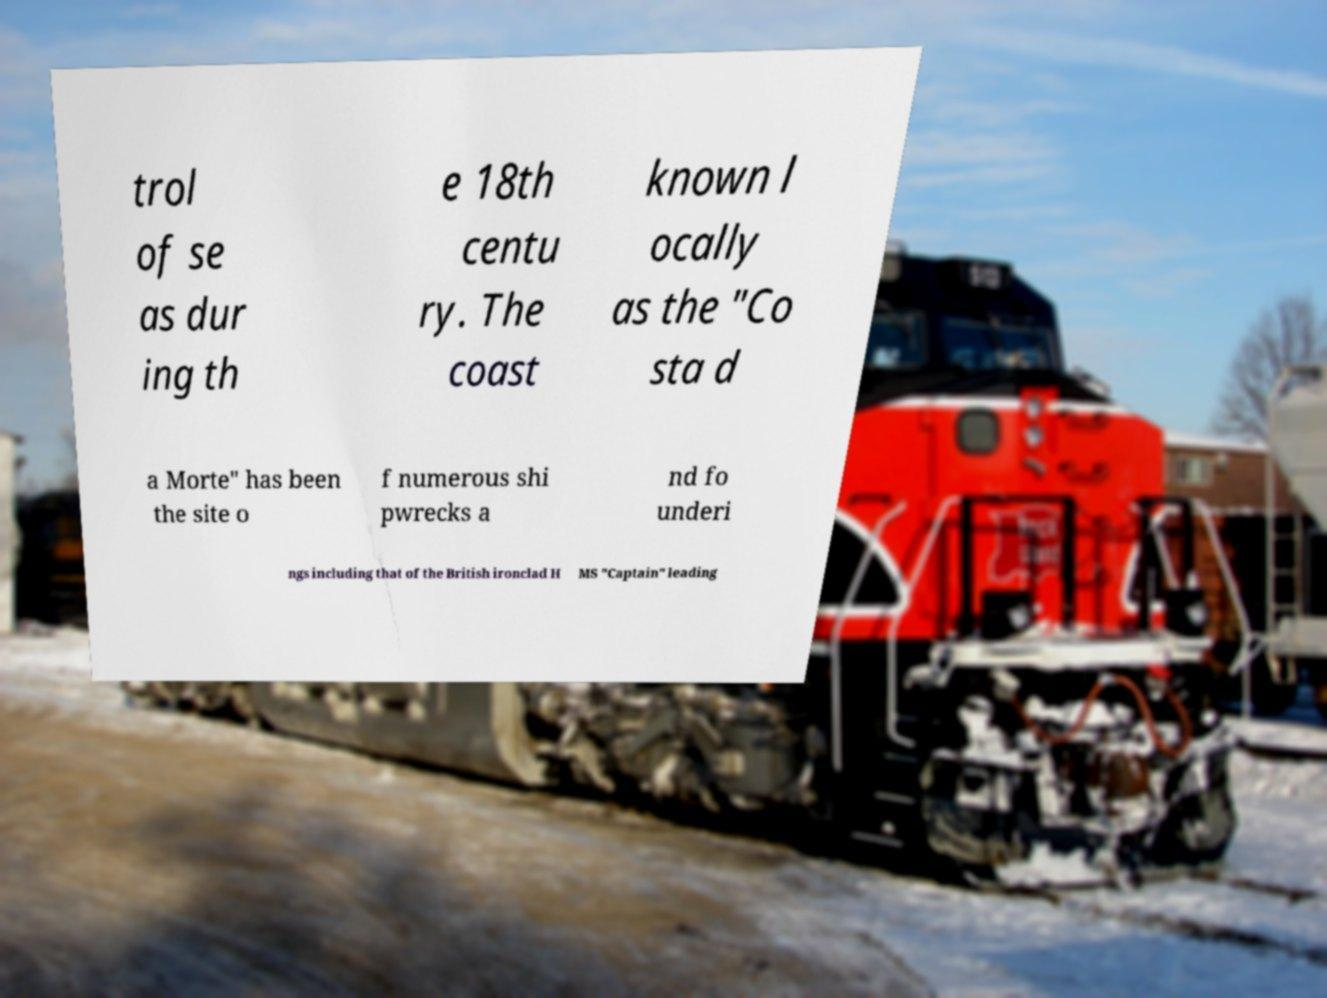What messages or text are displayed in this image? I need them in a readable, typed format. trol of se as dur ing th e 18th centu ry. The coast known l ocally as the "Co sta d a Morte" has been the site o f numerous shi pwrecks a nd fo underi ngs including that of the British ironclad H MS "Captain" leading 